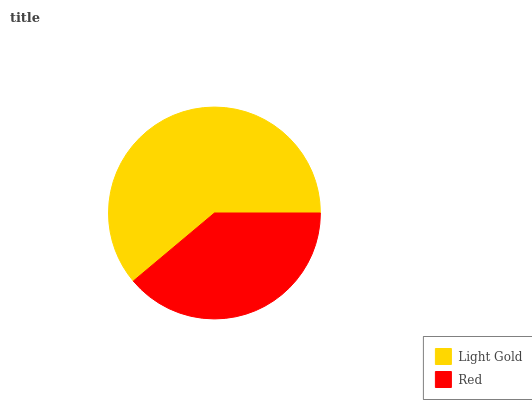Is Red the minimum?
Answer yes or no. Yes. Is Light Gold the maximum?
Answer yes or no. Yes. Is Red the maximum?
Answer yes or no. No. Is Light Gold greater than Red?
Answer yes or no. Yes. Is Red less than Light Gold?
Answer yes or no. Yes. Is Red greater than Light Gold?
Answer yes or no. No. Is Light Gold less than Red?
Answer yes or no. No. Is Light Gold the high median?
Answer yes or no. Yes. Is Red the low median?
Answer yes or no. Yes. Is Red the high median?
Answer yes or no. No. Is Light Gold the low median?
Answer yes or no. No. 